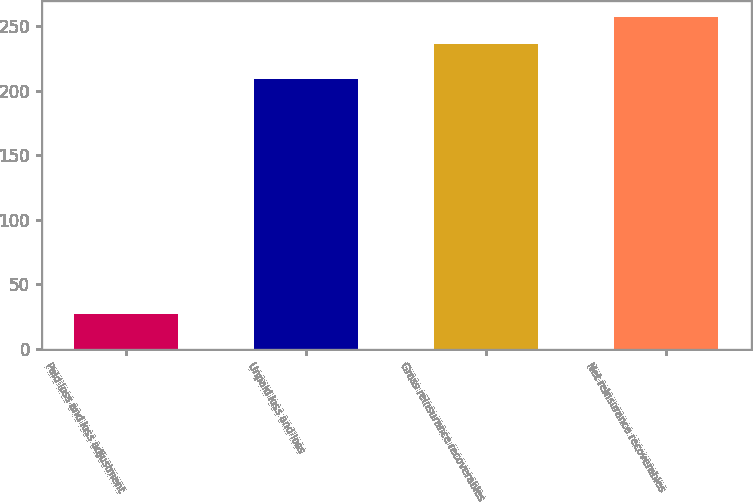Convert chart to OTSL. <chart><loc_0><loc_0><loc_500><loc_500><bar_chart><fcel>Paid loss and loss adjustment<fcel>Unpaid loss and loss<fcel>Gross reinsurance recoverables<fcel>Net reinsurance recoverables<nl><fcel>27<fcel>209<fcel>236<fcel>256.9<nl></chart> 